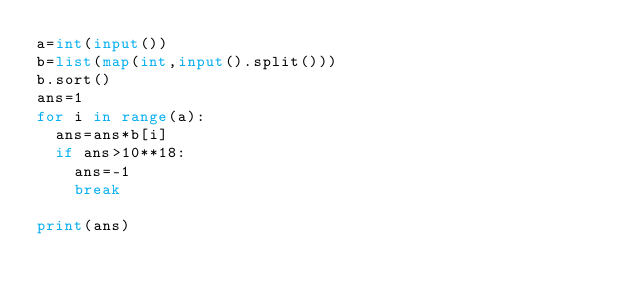Convert code to text. <code><loc_0><loc_0><loc_500><loc_500><_Python_>a=int(input())
b=list(map(int,input().split()))
b.sort()
ans=1
for i in range(a):
  ans=ans*b[i]
  if ans>10**18:
    ans=-1
    break
  
print(ans)
</code> 